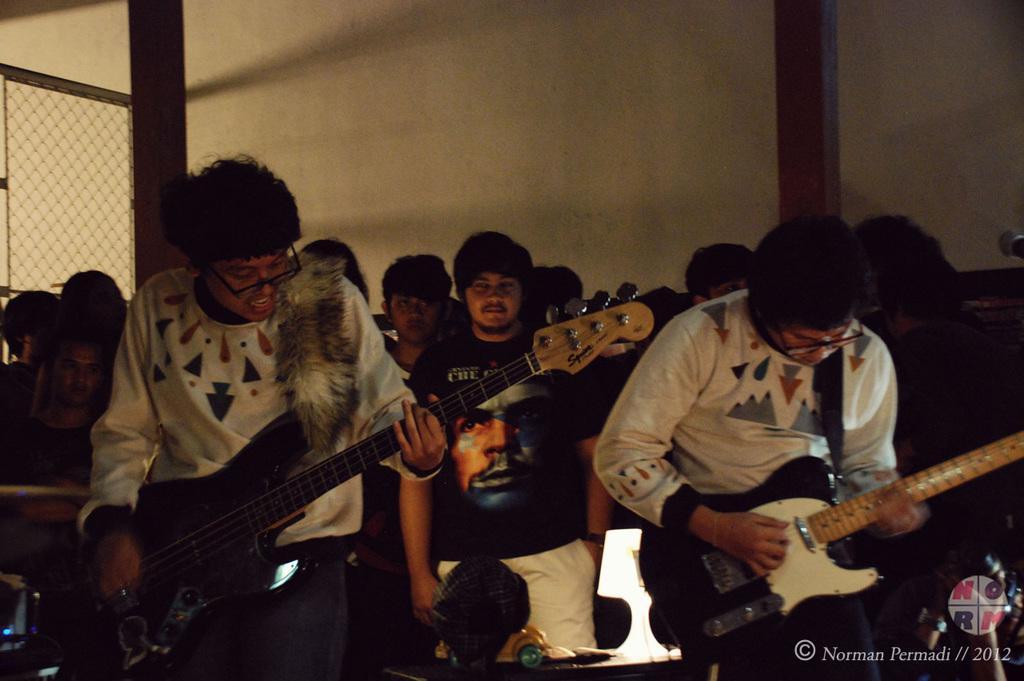Please provide a concise description of this image. In this image i can see group of people playing guitar at the back ground i can see a wall and a railing. 